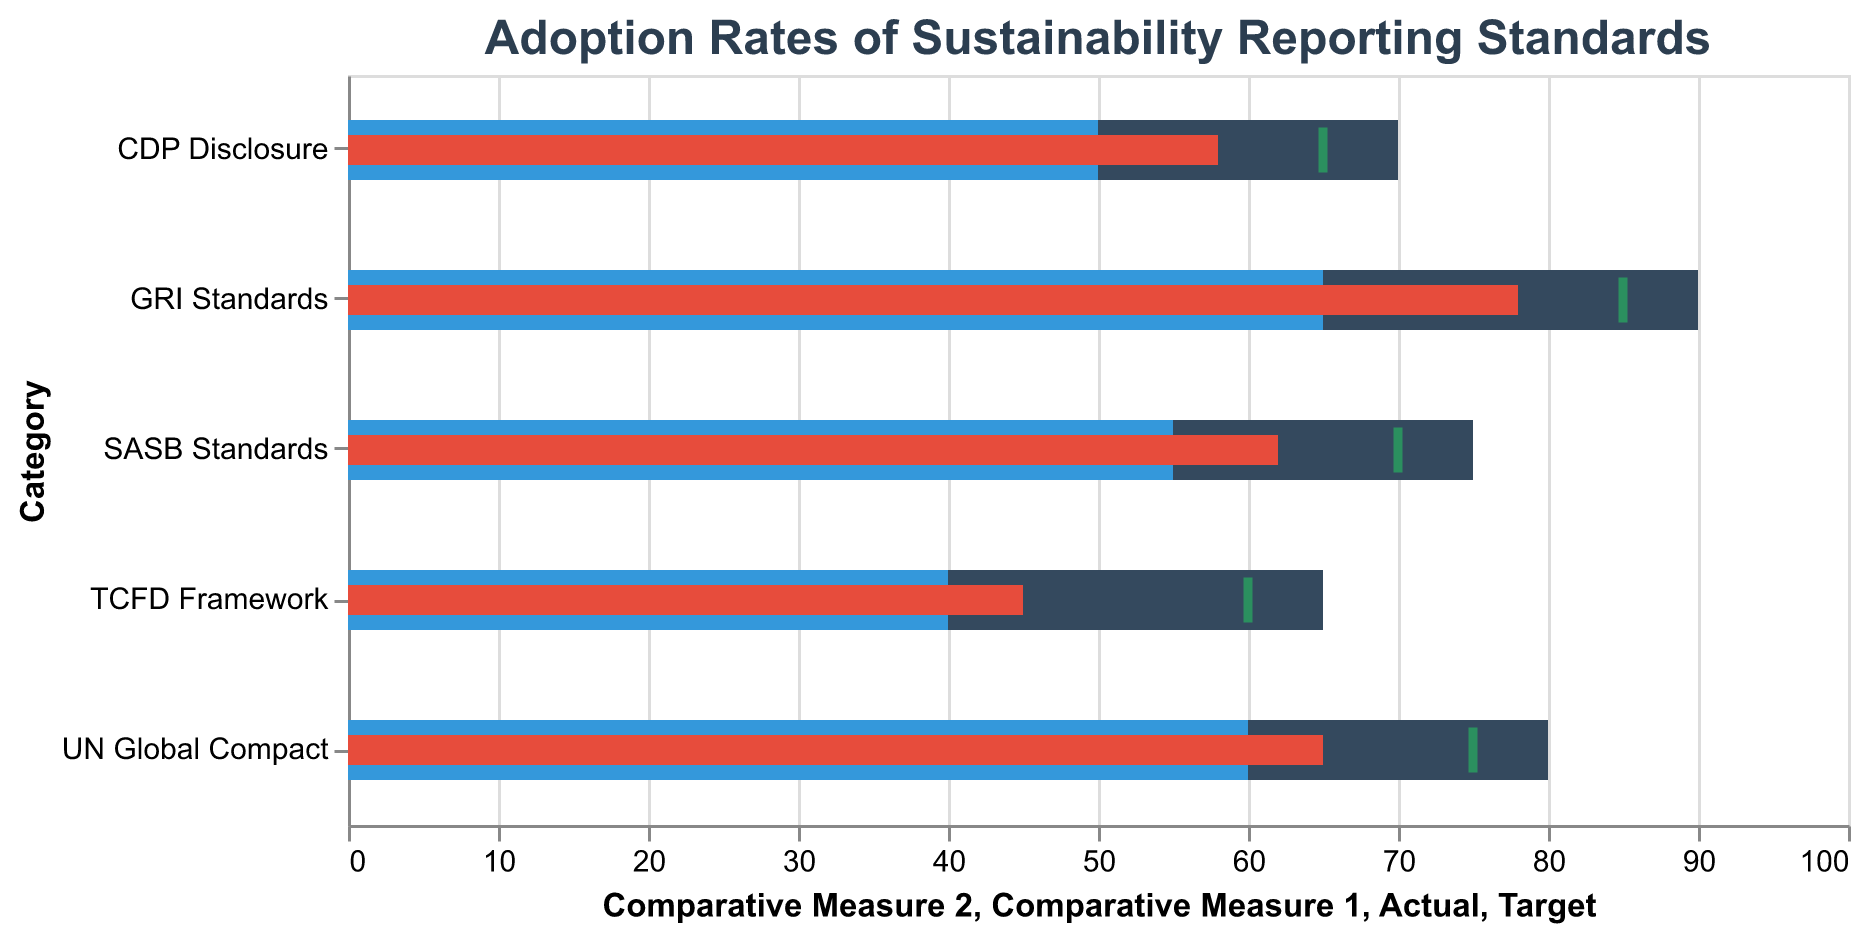What is the title of the chart? The title of the chart is displayed prominently at the top as "Adoption Rates of Sustainability Reporting Standards"
Answer: Adoption Rates of Sustainability Reporting Standards Which category has the highest actual adoption rate? To find the category with the highest actual adoption rate, look at the red bars and compare their lengths. The longest red bar corresponds to "GRI Standards" at 78.
Answer: GRI Standards What is the target adoption rate for the TCFD Framework? The target adoption rate is indicated by a green tick mark for each category. For the TCFD Framework, the tick mark is at the 60 position.
Answer: 60 Which categories have a target adoption rate greater than 70? Examine the position of the green tick marks. Categories with tick marks greater than 70 include "GRI Standards," "UN Global Compact," and "CDP Disclosure."
Answer: GRI Standards, UN Global Compact, CDP Disclosure How much higher is the target adoption rate compared to the actual adoption rate for SASB Standards? Find the difference between the target and actual adoption rates. For SASB Standards, the target is 70, and the actual is 62. The difference is 70 - 62 = 8.
Answer: 8 Between which two comparative measures does the adoption rate of CDP Disclosure fall? For CDP Disclosure, the red bar falls between the lengths of the two blue bars. The comparative measures for CDP Disclosure are from 50 to 70, and the actual adoption rate (58) falls within this range.
Answer: 50 and 70 Which category has the smallest gap between the actual and target adoption rates? To find this, calculate the difference between the actual and target numbers for each category. For GRI Standards: 85 - 78 = 7, SASB Standards: 70 - 62 = 8, TCFD Framework: 60 - 45 = 15, UN Global Compact: 75 - 65 = 10, CDP Disclosure: 65 - 58 = 7. Both GRI Standards and CDP Disclosure have the smallest gap of 7.
Answer: GRI Standards, CDP Disclosure How does the actual adoption rate of the TCFD Framework compare to the lowest comparative measure? For the TCFD Framework, the actual rate is 45, and Comparative Measure 1 is 40. The actual adoption rate is higher than the lowest comparative measure.
Answer: Higher What is the average of the actual adoption rates across all categories? Sum the actual rates and divide by the number of categories. (78 + 62 + 45 + 65 + 58) / 5 = 308 / 5 = 61.6
Answer: 61.6 